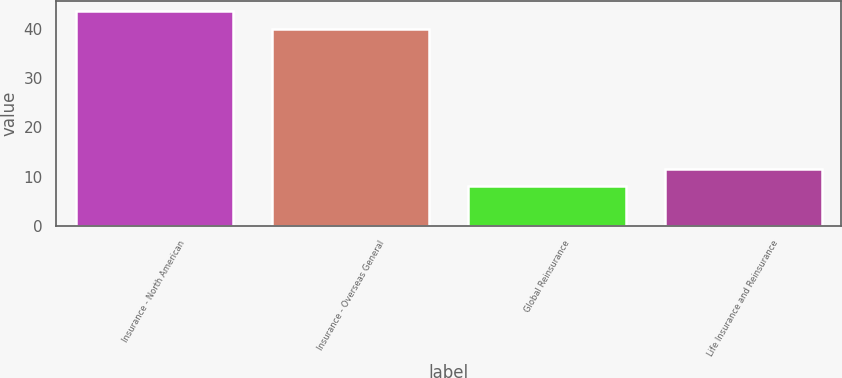Convert chart. <chart><loc_0><loc_0><loc_500><loc_500><bar_chart><fcel>Insurance - North American<fcel>Insurance - Overseas General<fcel>Global Reinsurance<fcel>Life Insurance and Reinsurance<nl><fcel>43.5<fcel>40<fcel>8<fcel>11.5<nl></chart> 